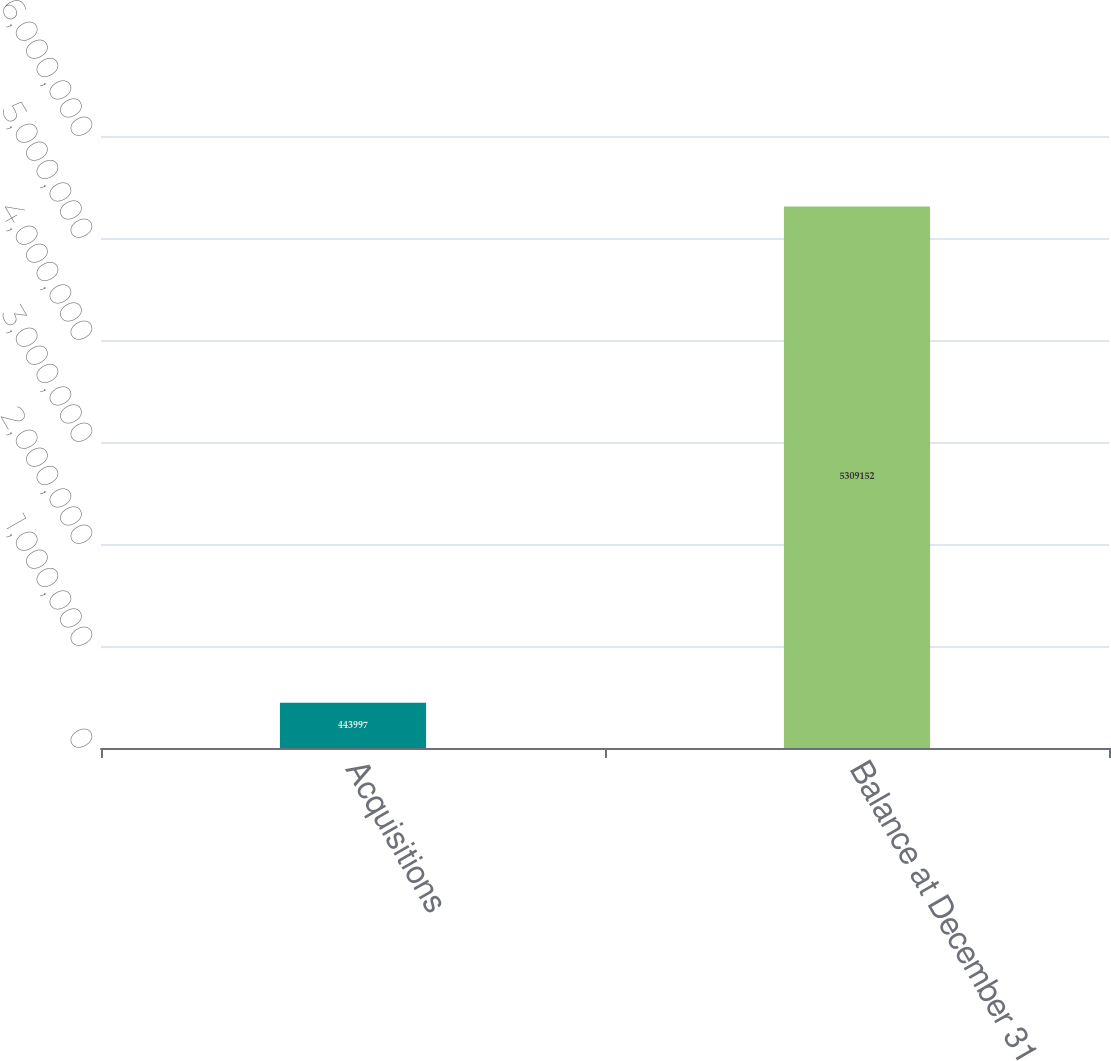<chart> <loc_0><loc_0><loc_500><loc_500><bar_chart><fcel>Acquisitions<fcel>Balance at December 31<nl><fcel>443997<fcel>5.30915e+06<nl></chart> 